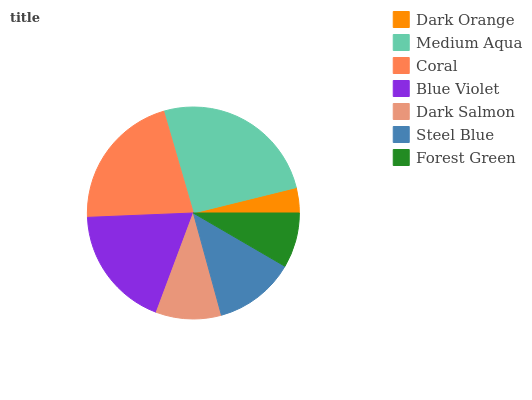Is Dark Orange the minimum?
Answer yes or no. Yes. Is Medium Aqua the maximum?
Answer yes or no. Yes. Is Coral the minimum?
Answer yes or no. No. Is Coral the maximum?
Answer yes or no. No. Is Medium Aqua greater than Coral?
Answer yes or no. Yes. Is Coral less than Medium Aqua?
Answer yes or no. Yes. Is Coral greater than Medium Aqua?
Answer yes or no. No. Is Medium Aqua less than Coral?
Answer yes or no. No. Is Steel Blue the high median?
Answer yes or no. Yes. Is Steel Blue the low median?
Answer yes or no. Yes. Is Forest Green the high median?
Answer yes or no. No. Is Medium Aqua the low median?
Answer yes or no. No. 